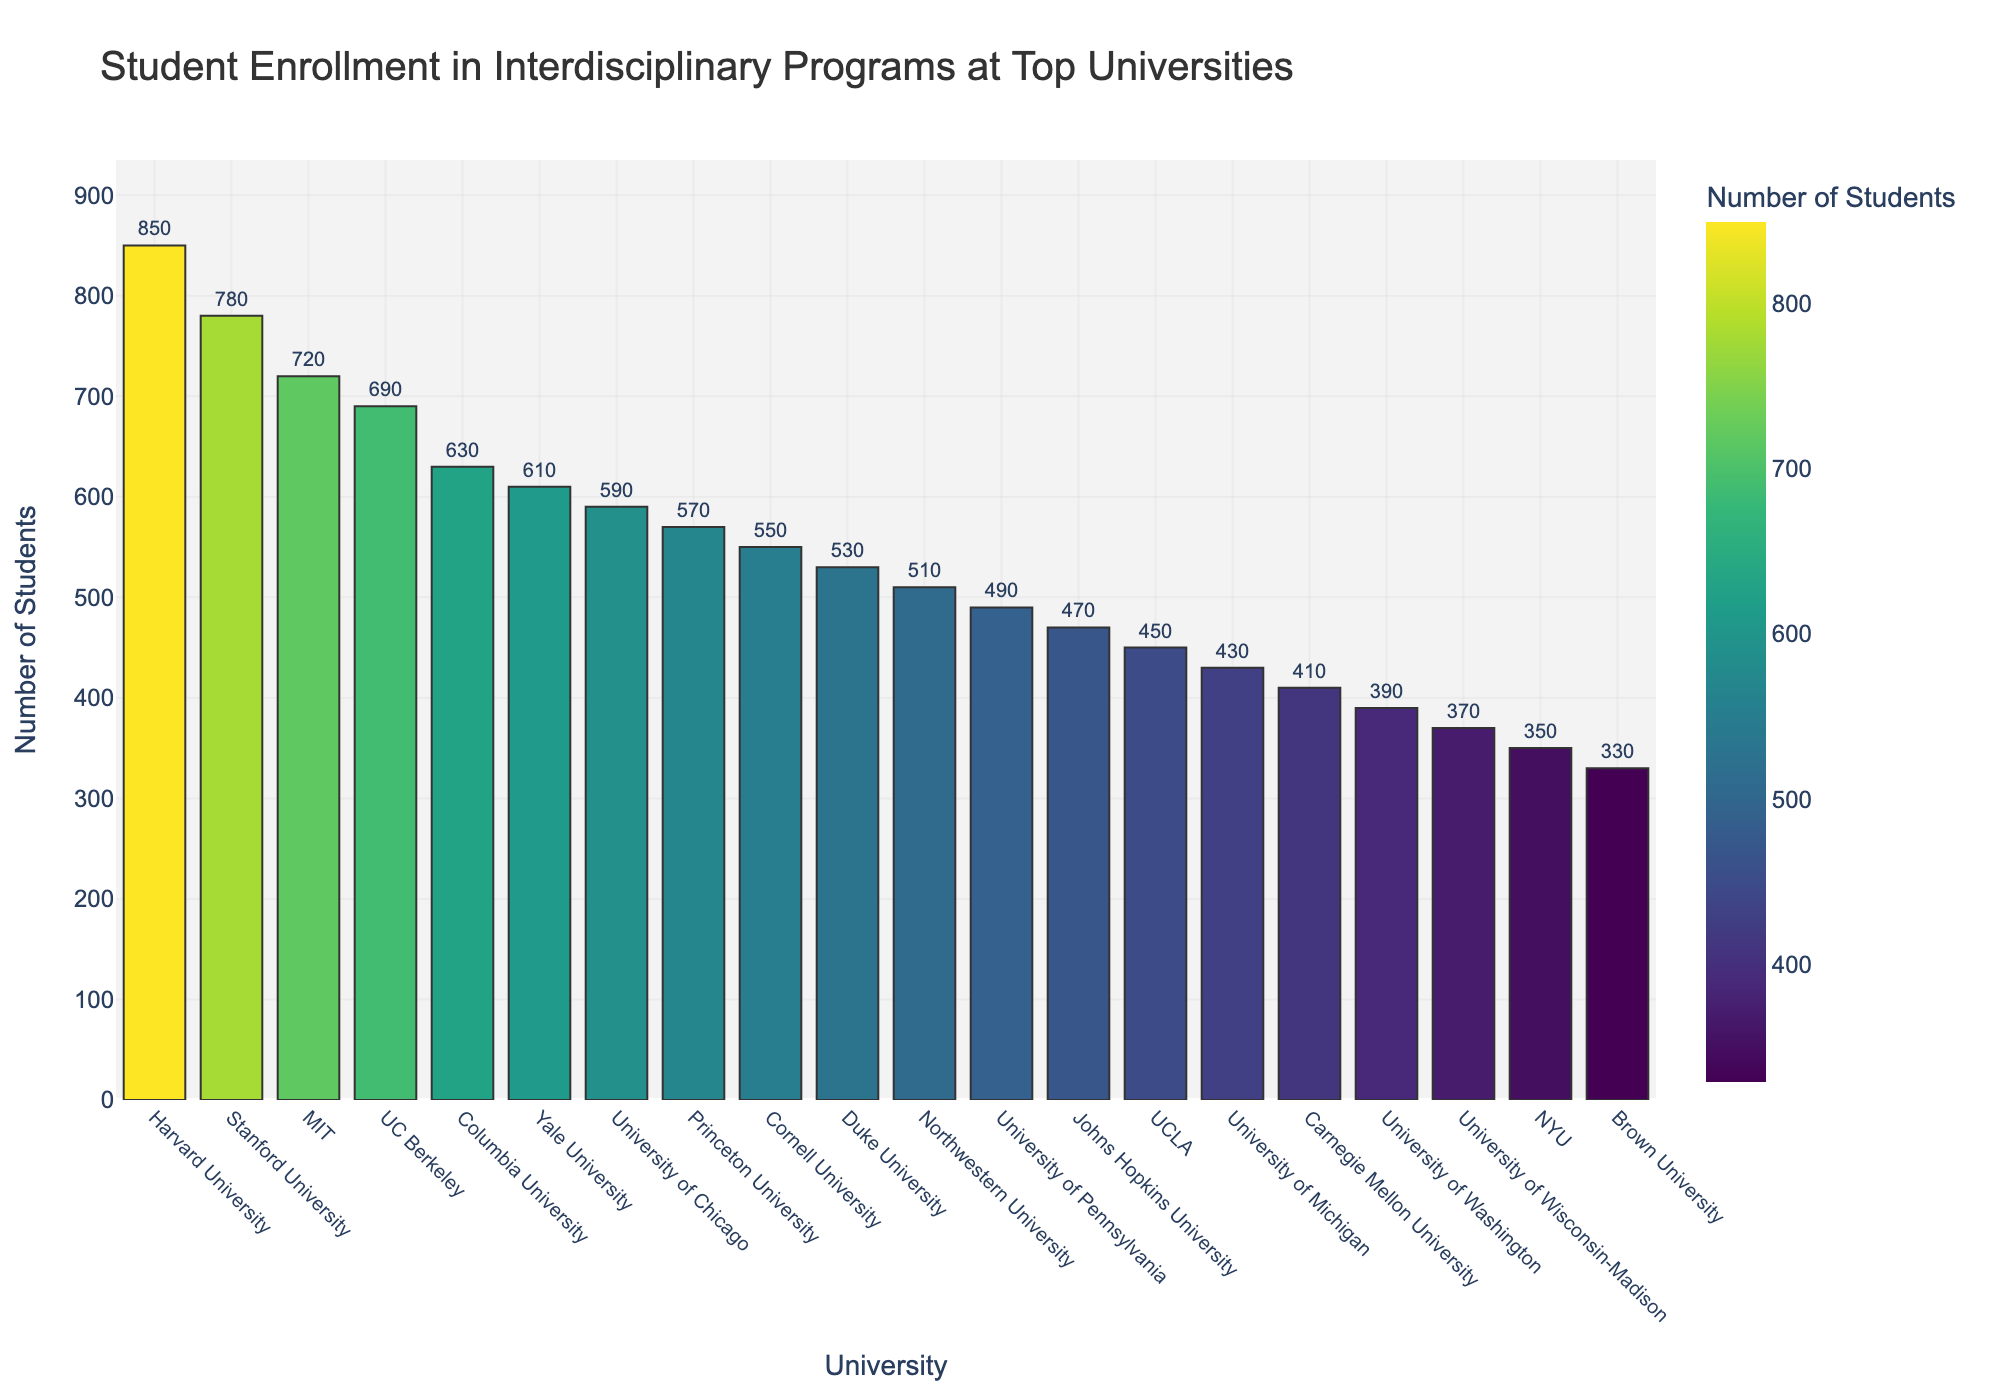Which university has the highest student enrollment in interdisciplinary programs? To find the university with the highest enrollment, look for the tallest bar in the bar chart. The tallest bar represents Harvard University.
Answer: Harvard University Which university has the lowest student enrollment in interdisciplinary programs? To determine the university with the lowest enrollment, identify the shortest bar in the bar chart. The shortest bar represents Brown University.
Answer: Brown University How many students are enrolled in interdisciplinary programs at Stanford University and MIT combined? First, find the bars representing Stanford University and MIT. The enrollments are 780 for Stanford and 720 for MIT. Summing them up: 780 + 720 = 1500.
Answer: 1500 Which university has a higher enrollment in interdisciplinary programs: Princeton University or Duke University? Locate the bars for Princeton University and Duke University. Princeton University has an enrollment of 570, while Duke University has 530. 570 is greater than 530.
Answer: Princeton University What is the difference in student enrollment between the University of Chicago and Columbia University? Locate the bars for the University of Chicago (590) and Columbia University (630). Subtract the smaller number from the larger one: 630 - 590 = 40.
Answer: 40 What is the average student enrollment in interdisciplinary programs across the top four universities listed? The top four universities listed are Harvard University (850), Stanford University (780), MIT (720), and UC Berkeley (690). Sum these enrollments: 850 + 780 + 720 + 690 = 3040. Divide by 4: 3040 / 4 = 760.
Answer: 760 What is the total student enrollment in interdisciplinary programs across all the universities in the chart? Sum the enrollments of all universities: 850 + 780 + 720 + 690 + 630 + 610 + 590 + 570 + 550 + 530 + 510 + 490 + 470 + 450 + 430 + 410 + 390 + 370 + 350 + 330. The total is 11230.
Answer: 11230 How many universities have an interdisciplinary enrollment exceeding 600 students? Count the number of bars with a height corresponding to more than 600 students. They represent Harvard, Stanford, MIT, UC Berkeley, Columbia, and Yale—six universities in total.
Answer: 6 What is the enrollment difference between the universities in the first and last positions of the chart? The first position is Harvard University with 850 students and the last is Brown University with 330 students. The difference is: 850 - 330 = 520.
Answer: 520 